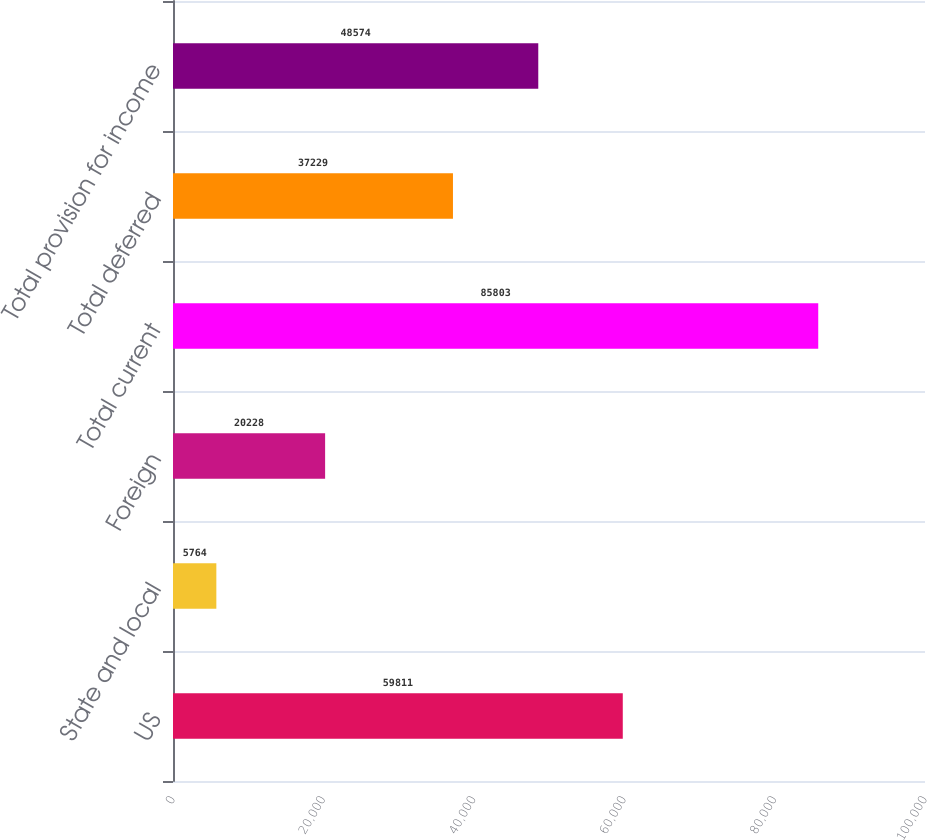Convert chart. <chart><loc_0><loc_0><loc_500><loc_500><bar_chart><fcel>US<fcel>State and local<fcel>Foreign<fcel>Total current<fcel>Total deferred<fcel>Total provision for income<nl><fcel>59811<fcel>5764<fcel>20228<fcel>85803<fcel>37229<fcel>48574<nl></chart> 